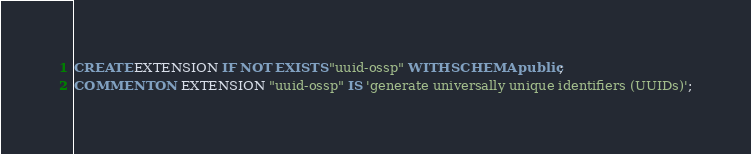Convert code to text. <code><loc_0><loc_0><loc_500><loc_500><_SQL_>CREATE EXTENSION IF NOT EXISTS "uuid-ossp" WITH SCHEMA public;
COMMENT ON EXTENSION "uuid-ossp" IS 'generate universally unique identifiers (UUIDs)';</code> 